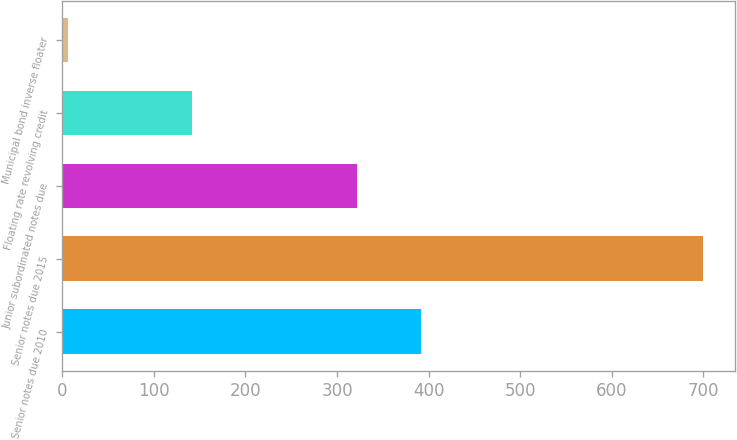Convert chart. <chart><loc_0><loc_0><loc_500><loc_500><bar_chart><fcel>Senior notes due 2010<fcel>Senior notes due 2015<fcel>Junior subordinated notes due<fcel>Floating rate revolving credit<fcel>Municipal bond inverse floater<nl><fcel>391.4<fcel>700<fcel>322<fcel>142<fcel>6<nl></chart> 